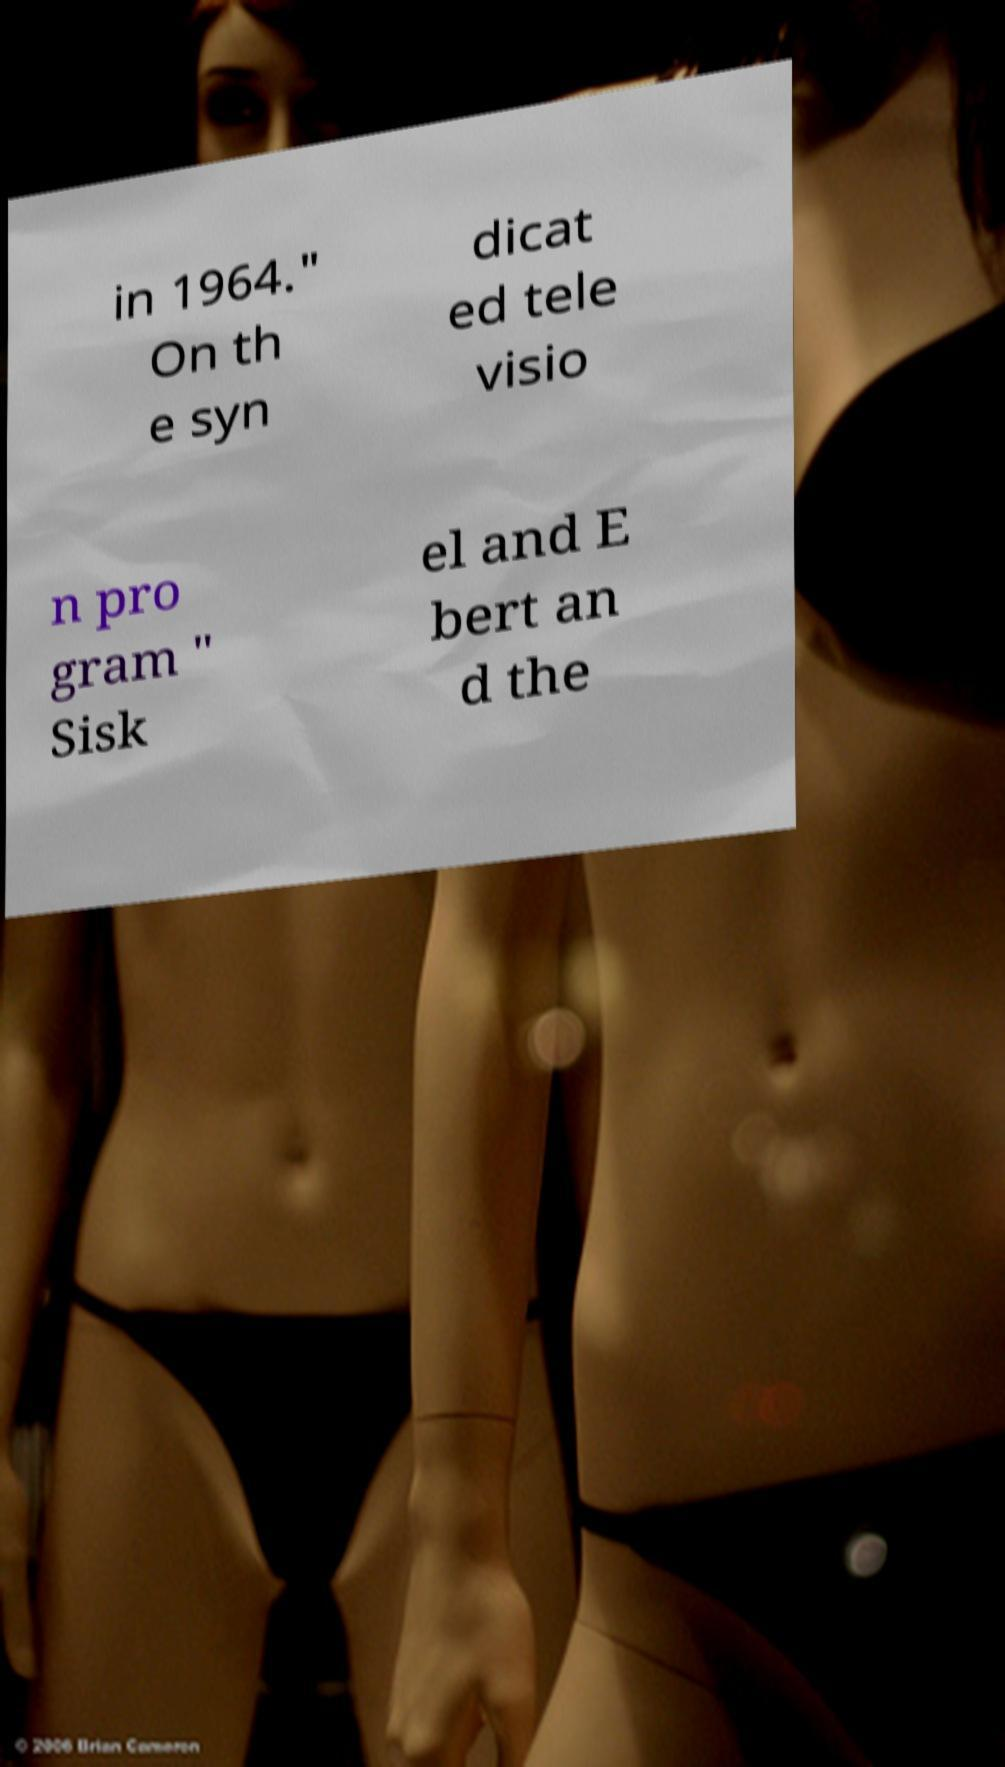Could you assist in decoding the text presented in this image and type it out clearly? in 1964." On th e syn dicat ed tele visio n pro gram " Sisk el and E bert an d the 